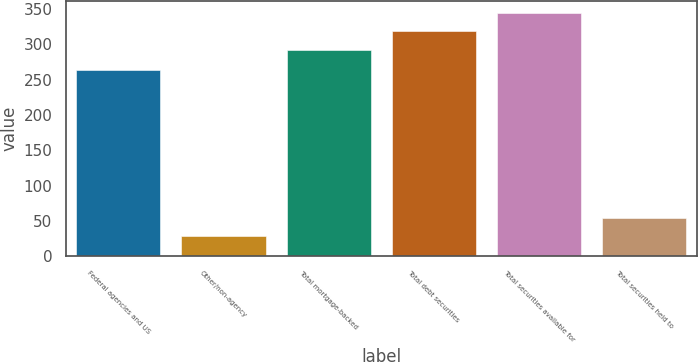Convert chart. <chart><loc_0><loc_0><loc_500><loc_500><bar_chart><fcel>Federal agencies and US<fcel>Other/non-agency<fcel>Total mortgage-backed<fcel>Total debt securities<fcel>Total securities available for<fcel>Total securities held to<nl><fcel>264<fcel>28<fcel>292<fcel>318.4<fcel>344.8<fcel>54.4<nl></chart> 